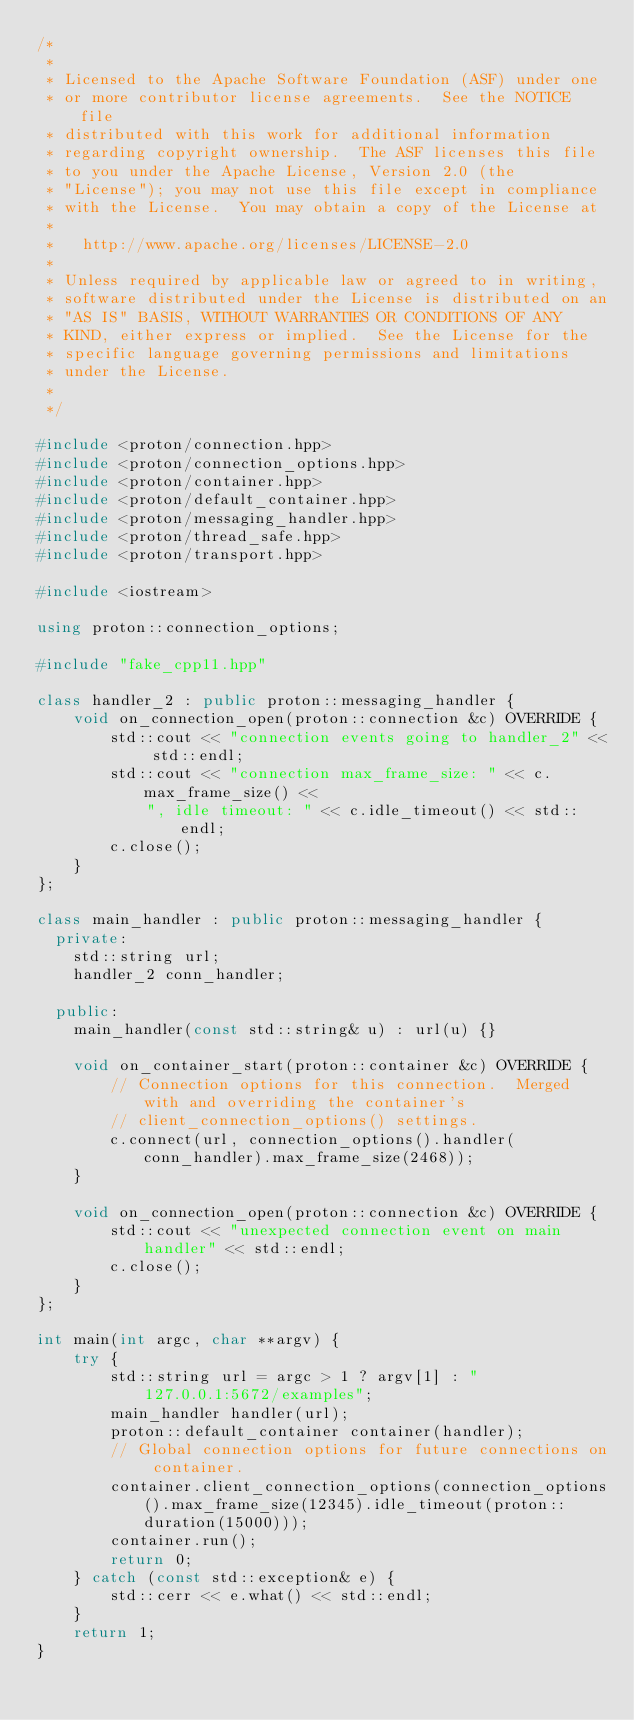Convert code to text. <code><loc_0><loc_0><loc_500><loc_500><_C++_>/*
 *
 * Licensed to the Apache Software Foundation (ASF) under one
 * or more contributor license agreements.  See the NOTICE file
 * distributed with this work for additional information
 * regarding copyright ownership.  The ASF licenses this file
 * to you under the Apache License, Version 2.0 (the
 * "License"); you may not use this file except in compliance
 * with the License.  You may obtain a copy of the License at
 *
 *   http://www.apache.org/licenses/LICENSE-2.0
 *
 * Unless required by applicable law or agreed to in writing,
 * software distributed under the License is distributed on an
 * "AS IS" BASIS, WITHOUT WARRANTIES OR CONDITIONS OF ANY
 * KIND, either express or implied.  See the License for the
 * specific language governing permissions and limitations
 * under the License.
 *
 */

#include <proton/connection.hpp>
#include <proton/connection_options.hpp>
#include <proton/container.hpp>
#include <proton/default_container.hpp>
#include <proton/messaging_handler.hpp>
#include <proton/thread_safe.hpp>
#include <proton/transport.hpp>

#include <iostream>

using proton::connection_options;

#include "fake_cpp11.hpp"

class handler_2 : public proton::messaging_handler {
    void on_connection_open(proton::connection &c) OVERRIDE {
        std::cout << "connection events going to handler_2" << std::endl;
        std::cout << "connection max_frame_size: " << c.max_frame_size() <<
            ", idle timeout: " << c.idle_timeout() << std::endl;
        c.close();
    }
};

class main_handler : public proton::messaging_handler {
  private:
    std::string url;
    handler_2 conn_handler;

  public:
    main_handler(const std::string& u) : url(u) {}

    void on_container_start(proton::container &c) OVERRIDE {
        // Connection options for this connection.  Merged with and overriding the container's
        // client_connection_options() settings.
        c.connect(url, connection_options().handler(conn_handler).max_frame_size(2468));
    }

    void on_connection_open(proton::connection &c) OVERRIDE {
        std::cout << "unexpected connection event on main handler" << std::endl;
        c.close();
    }
};

int main(int argc, char **argv) {
    try {
        std::string url = argc > 1 ? argv[1] : "127.0.0.1:5672/examples";
        main_handler handler(url);
        proton::default_container container(handler);
        // Global connection options for future connections on container.
        container.client_connection_options(connection_options().max_frame_size(12345).idle_timeout(proton::duration(15000)));
        container.run();
        return 0;
    } catch (const std::exception& e) {
        std::cerr << e.what() << std::endl;
    }
    return 1;
}
</code> 